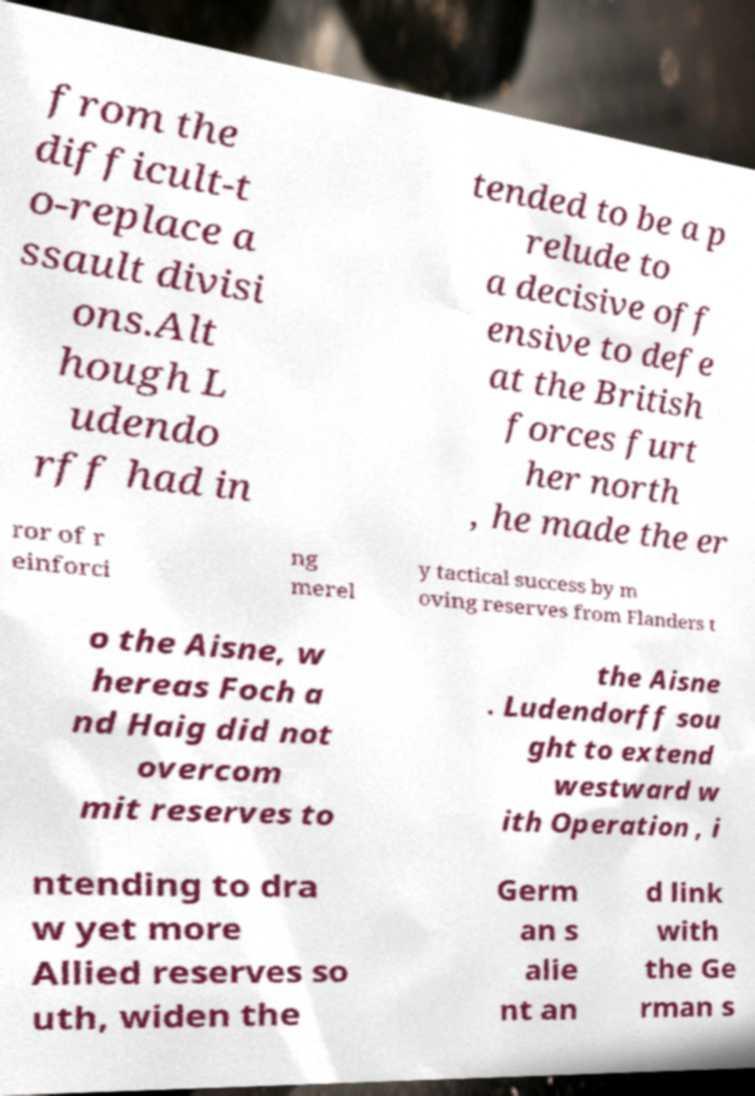For documentation purposes, I need the text within this image transcribed. Could you provide that? from the difficult-t o-replace a ssault divisi ons.Alt hough L udendo rff had in tended to be a p relude to a decisive off ensive to defe at the British forces furt her north , he made the er ror of r einforci ng merel y tactical success by m oving reserves from Flanders t o the Aisne, w hereas Foch a nd Haig did not overcom mit reserves to the Aisne . Ludendorff sou ght to extend westward w ith Operation , i ntending to dra w yet more Allied reserves so uth, widen the Germ an s alie nt an d link with the Ge rman s 